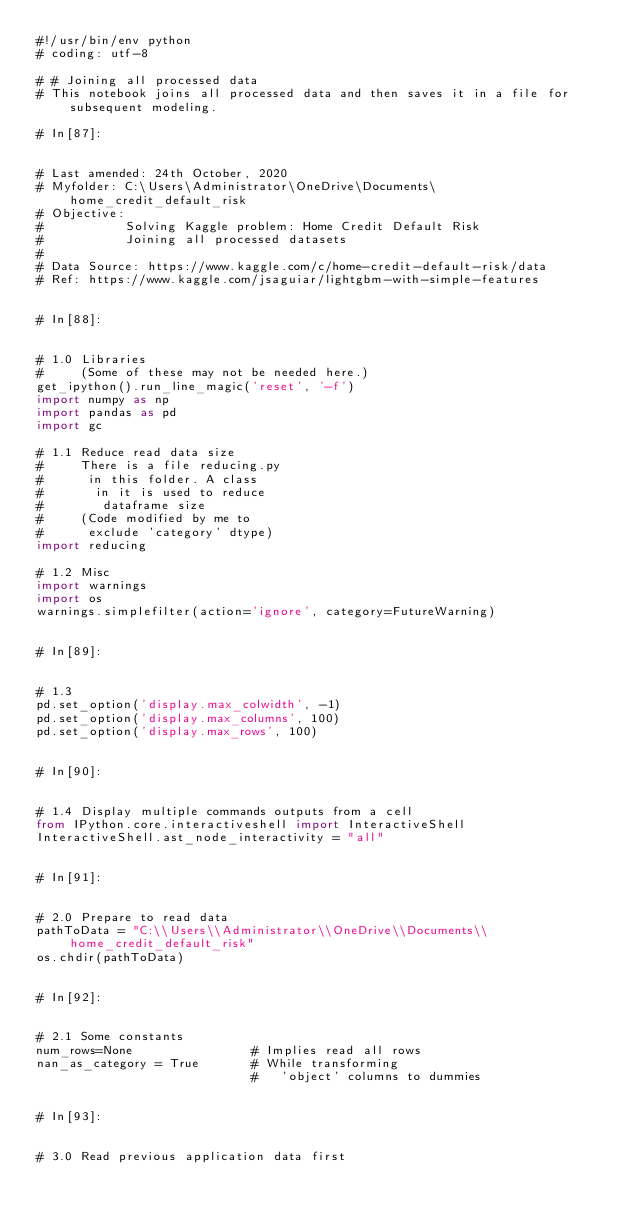<code> <loc_0><loc_0><loc_500><loc_500><_Python_>#!/usr/bin/env python
# coding: utf-8

# # Joining all processed data
# This notebook joins all processed data and then saves it in a file for subsequent modeling.

# In[87]:


# Last amended: 24th October, 2020
# Myfolder: C:\Users\Administrator\OneDrive\Documents\home_credit_default_risk
# Objective: 
#           Solving Kaggle problem: Home Credit Default Risk
#           Joining all processed datasets
#
# Data Source: https://www.kaggle.com/c/home-credit-default-risk/data
# Ref: https://www.kaggle.com/jsaguiar/lightgbm-with-simple-features


# In[88]:


# 1.0 Libraries
#     (Some of these may not be needed here.)
get_ipython().run_line_magic('reset', '-f')
import numpy as np
import pandas as pd
import gc

# 1.1 Reduce read data size
#     There is a file reducing.py
#      in this folder. A class
#       in it is used to reduce
#        dataframe size
#     (Code modified by me to
#      exclude 'category' dtype)
import reducing

# 1.2 Misc
import warnings
import os
warnings.simplefilter(action='ignore', category=FutureWarning)


# In[89]:


# 1.3
pd.set_option('display.max_colwidth', -1)
pd.set_option('display.max_columns', 100)
pd.set_option('display.max_rows', 100)


# In[90]:


# 1.4 Display multiple commands outputs from a cell
from IPython.core.interactiveshell import InteractiveShell
InteractiveShell.ast_node_interactivity = "all"


# In[91]:


# 2.0 Prepare to read data
pathToData = "C:\\Users\\Administrator\\OneDrive\\Documents\\home_credit_default_risk"
os.chdir(pathToData)


# In[92]:


# 2.1 Some constants
num_rows=None                # Implies read all rows
nan_as_category = True       # While transforming 
                             #   'object' columns to dummies


# In[93]:


# 3.0 Read previous application data first</code> 